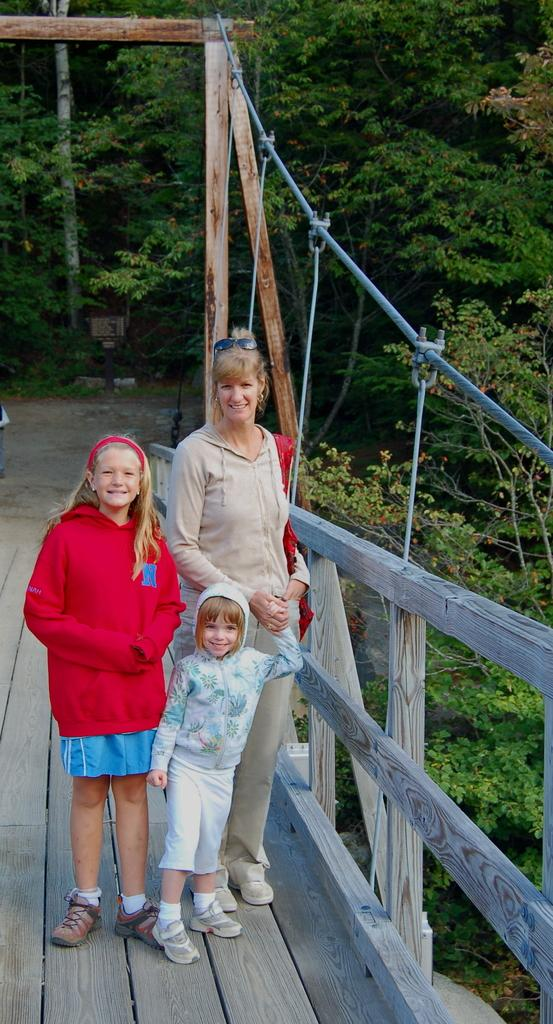What are the people in the image standing on? The people are standing on a wooden bridge in the image. What type of vegetation can be seen in the image? There are trees in the image. What is the color of the trees in the image? The trees are green in color. What other object can be seen in the image besides the bridge and trees? There is a pole visible in the image. What type of insect can be seen crawling on the pole in the image? There is no insect visible on the pole in the image. 